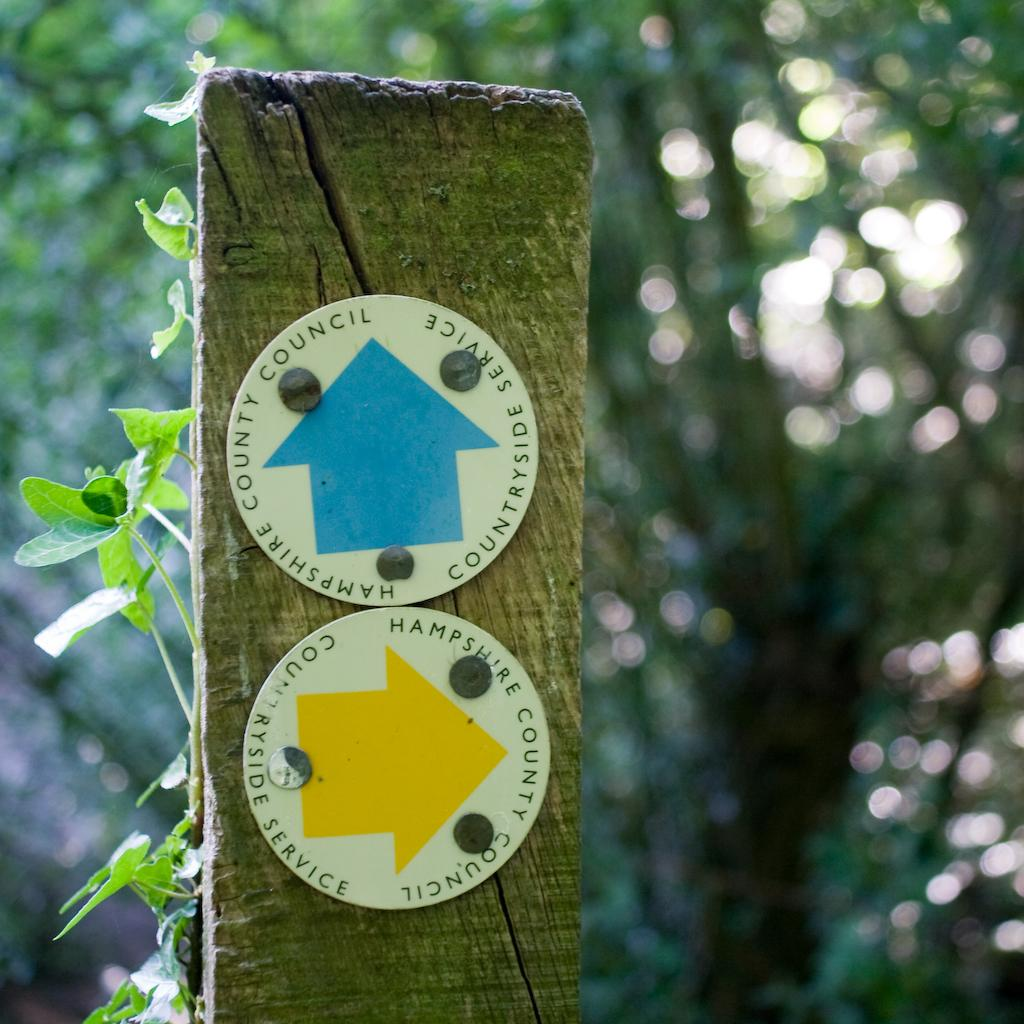What type of object is made of wood in the image? There is a wooden object in the image. What can be found on the wooden object? The wooden object has two boards with text. What is located near the wooden object? There is a plant beside the wooden object. How would you describe the background of the image? The background of the image is blurred. Can you see any sheep grazing on the slope in the image? There is no slope or sheep present in the image. What type of breakfast is being served on the wooden object in the image? There is no breakfast visible in the image; it only features a wooden object with text and a plant beside it. 